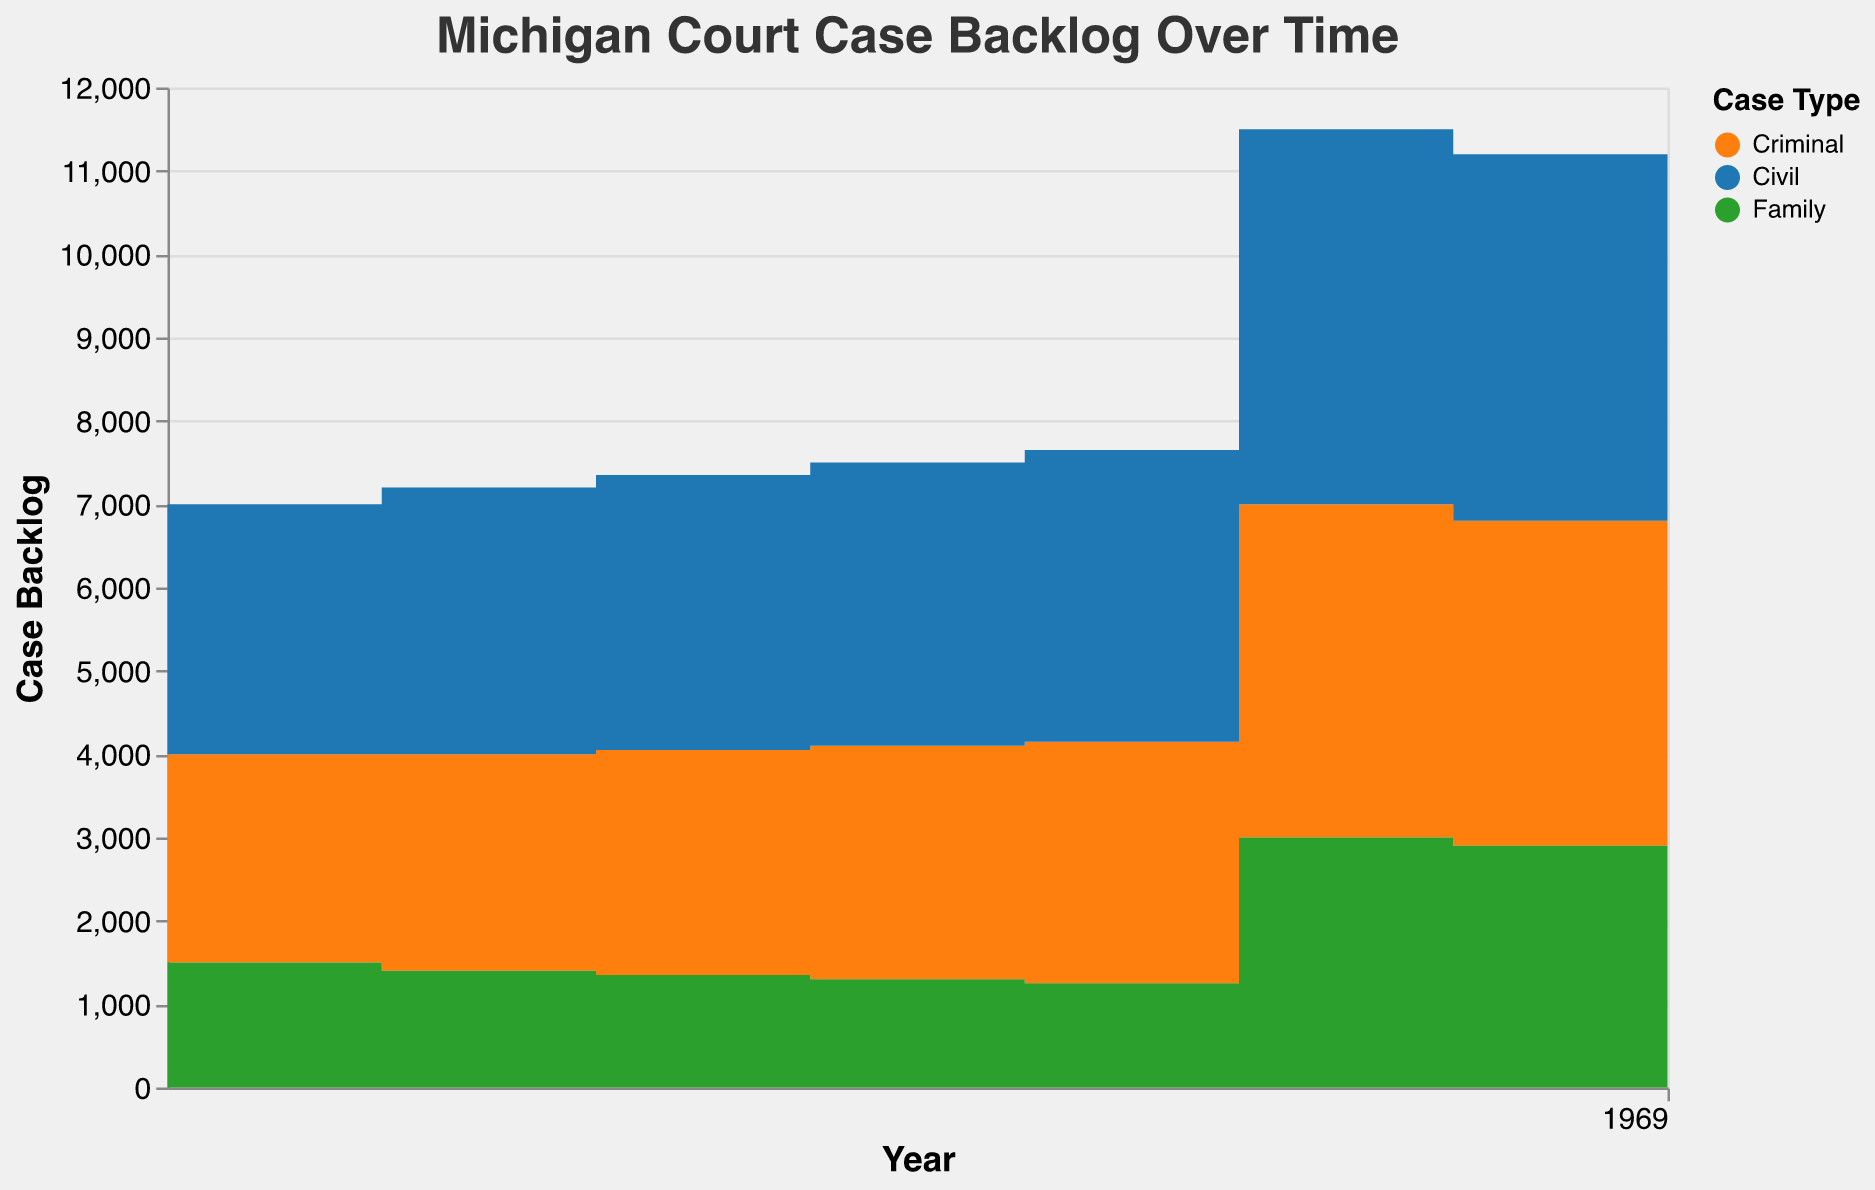What is the title of the chart? The title is prominently displayed at the top of the chart in a larger and bold font. The title reads "Michigan Court Case Backlog Over Time."
Answer: Michigan Court Case Backlog Over Time Which case type had the highest case backlog in 2020? Looking at the chart for the year 2020, the topmost section with the largest area represents the highest backlog case type. It's color-coded to differentiate between Criminal, Civil, and Family. Civil cases with encoded color have the highest backlog.
Answer: Civil How did the case backlog for Criminal cases change from 2019 to 2020? By observing the step-area chart from 2019 to 2020, we can see the step height increased for Criminal cases, indicating a rise in the backlog number.
Answer: Increased What is the total case backlog for all case types in 2022? To find the total, sum up the heights of each colored segment (Criminal, Civil, and Family) at the year 2022. The value is 3800 (Criminal) + 4300 (Civil) + 2800 (Family) = 10900.
Answer: 10900 Which year saw the most significant increase in case backlog for Family cases? By comparing the heights of the green section of the step-area chart between consecutive years, 2019 to 2020 shows the most significant increase in backlog for Family cases.
Answer: 2020 What is the difference in the case backlog between Civil and Criminal cases in 2021? The chart places Civil above Criminal in terms of backlog values. In 2021, the backlog values are 4400 for Civil and 3900 for Criminal. The difference is 4400 - 3900 = 500.
Answer: 500 How did the resolution time for Civil cases trend over the period from 2015 to 2022? Although not directly visible in the step area chart, the trend can be summarized as generally increasing from 225 days in 2015 to 260 days in 2022.
Answer: Increasing What year had the smallest difference between the Criminal and Family case backlogs? Reviewing the values across years, 2015 has the smallest difference: 2500 (Criminal) - 1500 (Family) = 1000, which is less than other years' differences.
Answer: 2015 How does the total case backlog in 2018 compare to 2022? To compare the totals, sum up the respective values for each case type for both years and then assess. In 2018: 2800 (Criminal) + 3400 (Civil) + 1300 (Family) = 7500. In 2022: 3800 (Criminal) + 4300 (Civil) + 2800 (Family) = 10900. 2022 has a higher backlog.
Answer: 2022 is higher How did the Family case backlog trend from 2015 to 2022? Observing the trend line formed by the green areas from 2015 to 2022, the overall pattern reflects a downward trend, peaking in 2020 and then reducing.
Answer: Decreasing 